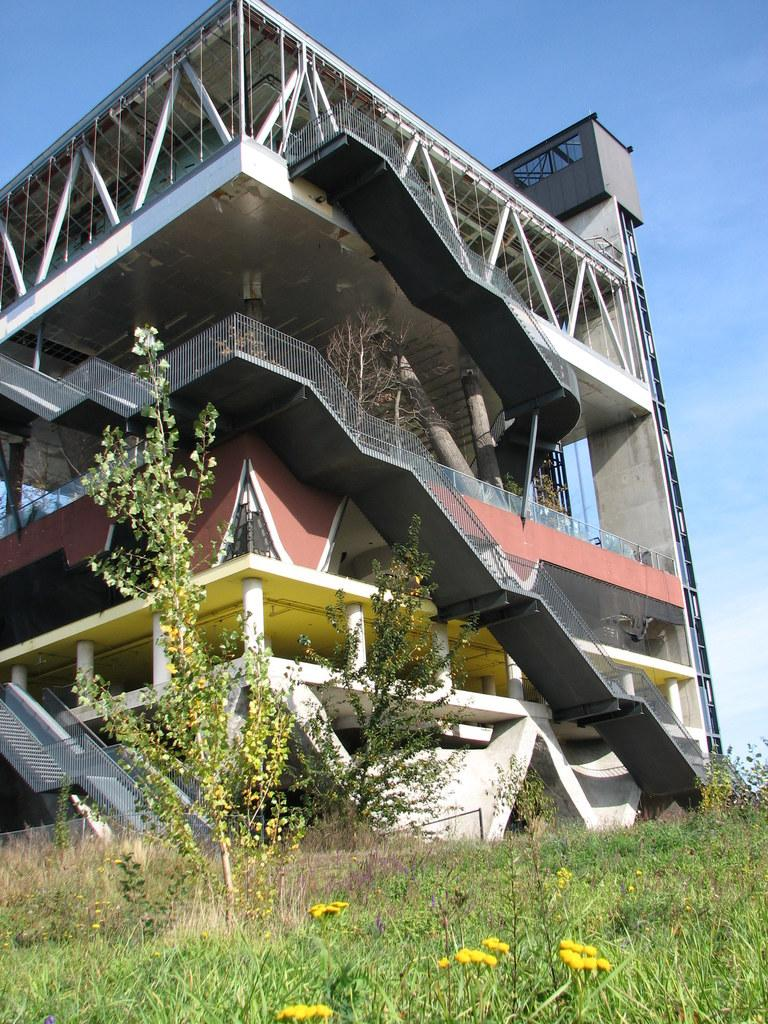What type of vegetation can be seen in the image? There is grass, plants, and flowers in the image. What type of structure is present in the image? There is a building in the image. What can be seen in the background of the image? The sky is visible in the background of the image. How many eggs are visible in the image? There are no eggs present in the image. What type of iron object is being used to water the plants in the image? There is no iron object or watering activity depicted in the image. 